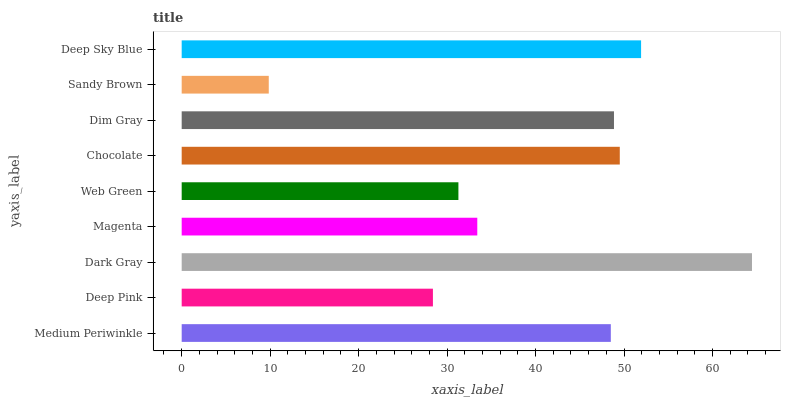Is Sandy Brown the minimum?
Answer yes or no. Yes. Is Dark Gray the maximum?
Answer yes or no. Yes. Is Deep Pink the minimum?
Answer yes or no. No. Is Deep Pink the maximum?
Answer yes or no. No. Is Medium Periwinkle greater than Deep Pink?
Answer yes or no. Yes. Is Deep Pink less than Medium Periwinkle?
Answer yes or no. Yes. Is Deep Pink greater than Medium Periwinkle?
Answer yes or no. No. Is Medium Periwinkle less than Deep Pink?
Answer yes or no. No. Is Medium Periwinkle the high median?
Answer yes or no. Yes. Is Medium Periwinkle the low median?
Answer yes or no. Yes. Is Web Green the high median?
Answer yes or no. No. Is Deep Pink the low median?
Answer yes or no. No. 